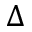<formula> <loc_0><loc_0><loc_500><loc_500>\Delta</formula> 